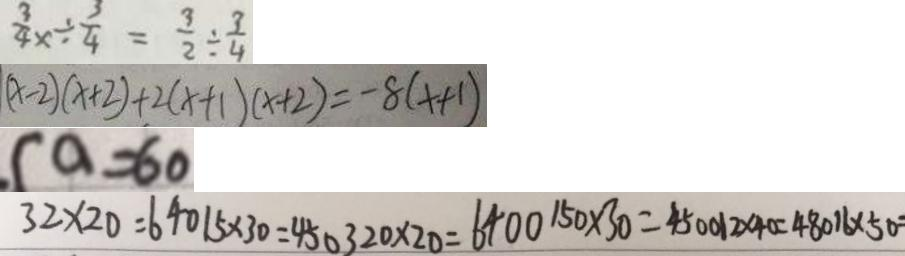Convert formula to latex. <formula><loc_0><loc_0><loc_500><loc_500>\frac { 3 } { 4 } x \div \frac { 3 } { 4 } = \frac { 3 } { 2 } \div \frac { 3 } { 4 } 
 ( x - 2 ) ( x + 2 ) + 2 ( x + 1 ) ( x + 2 ) = - 8 ( x + 1 ) 
 ( a = 6 0 
 3 2 \times 2 0 = 6 4 0 1 5 \times 3 0 = 4 5 0 3 2 0 \times 2 0 = 6 4 0 0 1 5 0 \times 3 0 = 4 5 0 0 1 2 \times 4 0 = 4 8 0 1 6 \times 5 0</formula> 